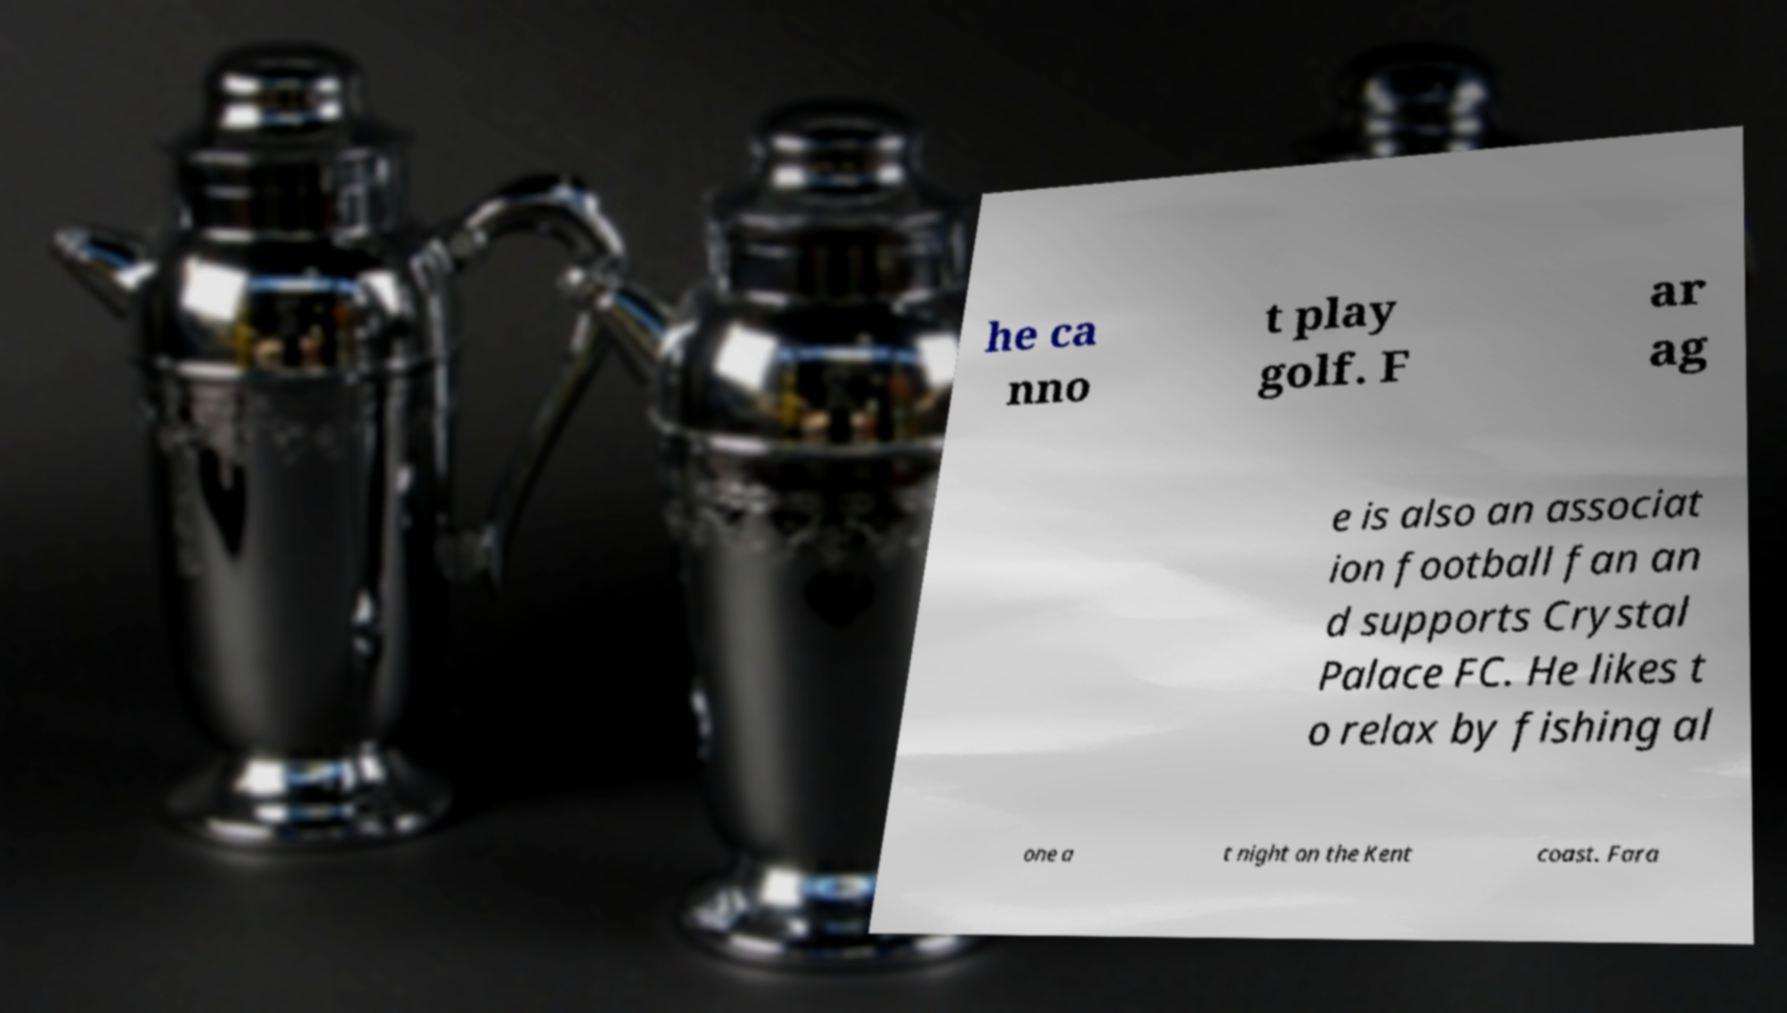I need the written content from this picture converted into text. Can you do that? he ca nno t play golf. F ar ag e is also an associat ion football fan an d supports Crystal Palace FC. He likes t o relax by fishing al one a t night on the Kent coast. Fara 